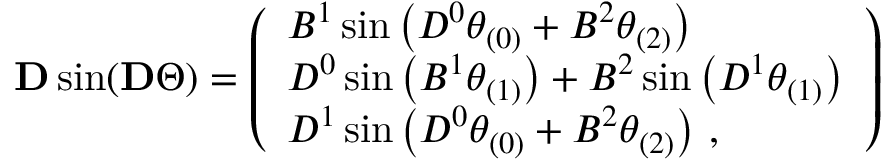<formula> <loc_0><loc_0><loc_500><loc_500>\begin{array} { r } { D \sin ( D \Theta ) = \left ( \begin{array} { l } { B ^ { 1 } \sin \left ( D ^ { 0 } \theta _ { ( 0 ) } + B ^ { 2 } \theta _ { ( 2 ) } \right ) } \\ { D ^ { 0 } \sin \left ( B ^ { 1 } \theta _ { ( 1 ) } \right ) + B ^ { 2 } \sin \left ( D ^ { 1 } \theta _ { ( 1 ) } \right ) } \\ { D ^ { 1 } \sin \left ( D ^ { 0 } \theta _ { ( 0 ) } + B ^ { 2 } \theta _ { ( 2 ) } \right ) \, , } \end{array} \right ) } \end{array}</formula> 